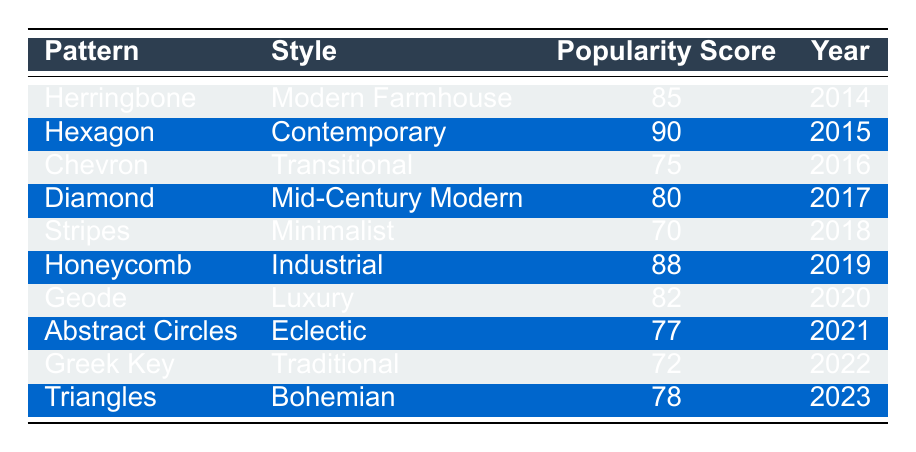What is the most popular geometric pattern in the table? The highest popularity score in the table is 90, which corresponds to the Hexagon pattern used in the Contemporary style in 2015.
Answer: Hexagon Which geometric pattern had the lowest popularity score? The lowest popularity score in the table is 70, which belongs to the Stripes pattern used in the Minimalist style in 2018.
Answer: Stripes Is the Diamond pattern more popular than the Chevron pattern? The popularity score for Diamond is 80 and for Chevron is 75. Since 80 is greater than 75, the Diamond pattern is indeed more popular.
Answer: Yes What is the average popularity score of the patterns listed in the table? To find the average, add all popularity scores: (85 + 90 + 75 + 80 + 70 + 88 + 82 + 77 + 72 + 78) =  807. There are 10 patterns, so the average is 807/10 = 80.7.
Answer: 80.7 Which styles have a popularity score above 80, and how many of them are there? The patterns with a score above 80 are Herringbone (85), Hexagon (90), Honeycomb (88), and Geode (82). There are 4 patterns with scores above 80.
Answer: 4 Has the popularity of geometric patterns increased or decreased over the years? By comparing the scores chronologically from 2014 to 2023, I see a general trend with scores oscillating up and down. The highest score is in 2015 and the lowest in 2018, but there also was an increase in scores after 2018. This indicates variability rather than a strictly increasing or decreasing trend over the years.
Answer: Variability Which geometric pattern is associated with the Bohemian style? The pattern associated with the Bohemian style is Triangles, which has a popularity score of 78 in 2023.
Answer: Triangles Was the Honeycomb pattern popular in the year 2019? Yes, the Honeycomb pattern had a popularity score of 88 in 2019, which is considered high.
Answer: Yes What is the difference in popularity score between the most and least popular patterns? The difference is calculated by subtracting the lowest score (70 for Stripes) from the highest score (90 for Hexagon): 90 - 70 = 20.
Answer: 20 